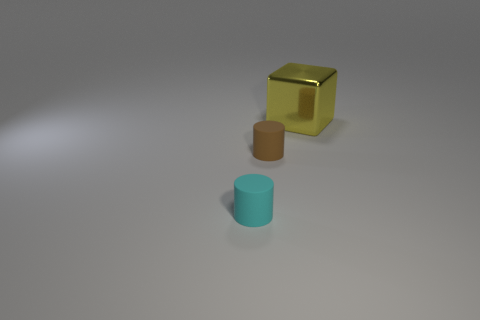There is a matte thing on the right side of the rubber cylinder to the left of the brown thing; what is its shape?
Provide a short and direct response. Cylinder. The tiny matte thing that is to the right of the cyan object has what shape?
Your response must be concise. Cylinder. What number of green objects are either matte cylinders or large matte blocks?
Provide a short and direct response. 0. How big is the rubber thing behind the small rubber cylinder that is left of the brown cylinder?
Your answer should be compact. Small. What number of other objects are the same size as the yellow metallic block?
Keep it short and to the point. 0. How many cylinders are either brown objects or yellow metal things?
Give a very brief answer. 1. Is there anything else that has the same material as the large yellow block?
Your answer should be very brief. No. There is a tiny thing behind the tiny rubber cylinder that is in front of the tiny rubber object that is behind the cyan cylinder; what is it made of?
Provide a succinct answer. Rubber. What number of small cylinders are the same material as the small cyan thing?
Keep it short and to the point. 1. Is the size of the rubber object to the right of the cyan cylinder the same as the cyan cylinder?
Your response must be concise. Yes. 